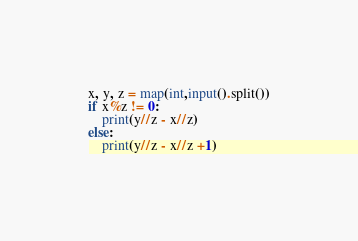<code> <loc_0><loc_0><loc_500><loc_500><_Python_>x, y, z = map(int,input().split())
if x%z != 0:
    print(y//z - x//z)
else:
    print(y//z - x//z +1)</code> 